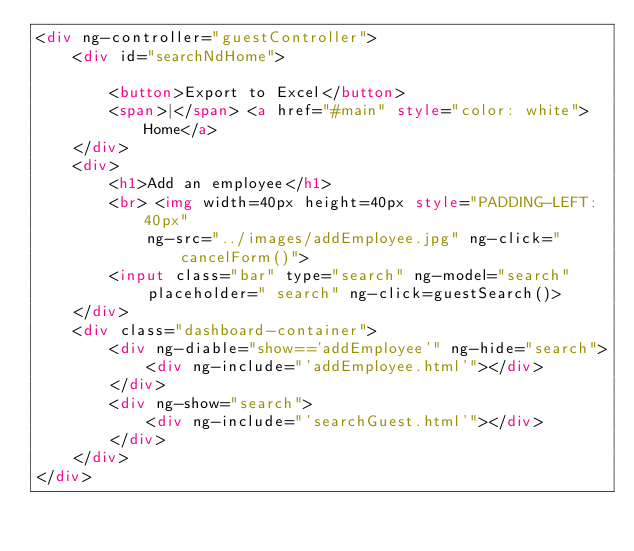<code> <loc_0><loc_0><loc_500><loc_500><_HTML_><div ng-controller="guestController">
	<div id="searchNdHome">
		
		<button>Export to Excel</button>
		<span>|</span> <a href="#main" style="color: white">Home</a>
	</div>
	<div>
		<h1>Add an employee</h1>
		<br> <img width=40px height=40px style="PADDING-LEFT: 40px"
			ng-src="../images/addEmployee.jpg" ng-click="cancelForm()">
		<input class="bar" type="search" ng-model="search"
			placeholder=" search" ng-click=guestSearch()>
	</div>
	<div class="dashboard-container">
		<div ng-diable="show=='addEmployee'" ng-hide="search">
			<div ng-include="'addEmployee.html'"></div>
		</div>
		<div ng-show="search">
			<div ng-include="'searchGuest.html'"></div>
		</div>
	</div>
</div></code> 